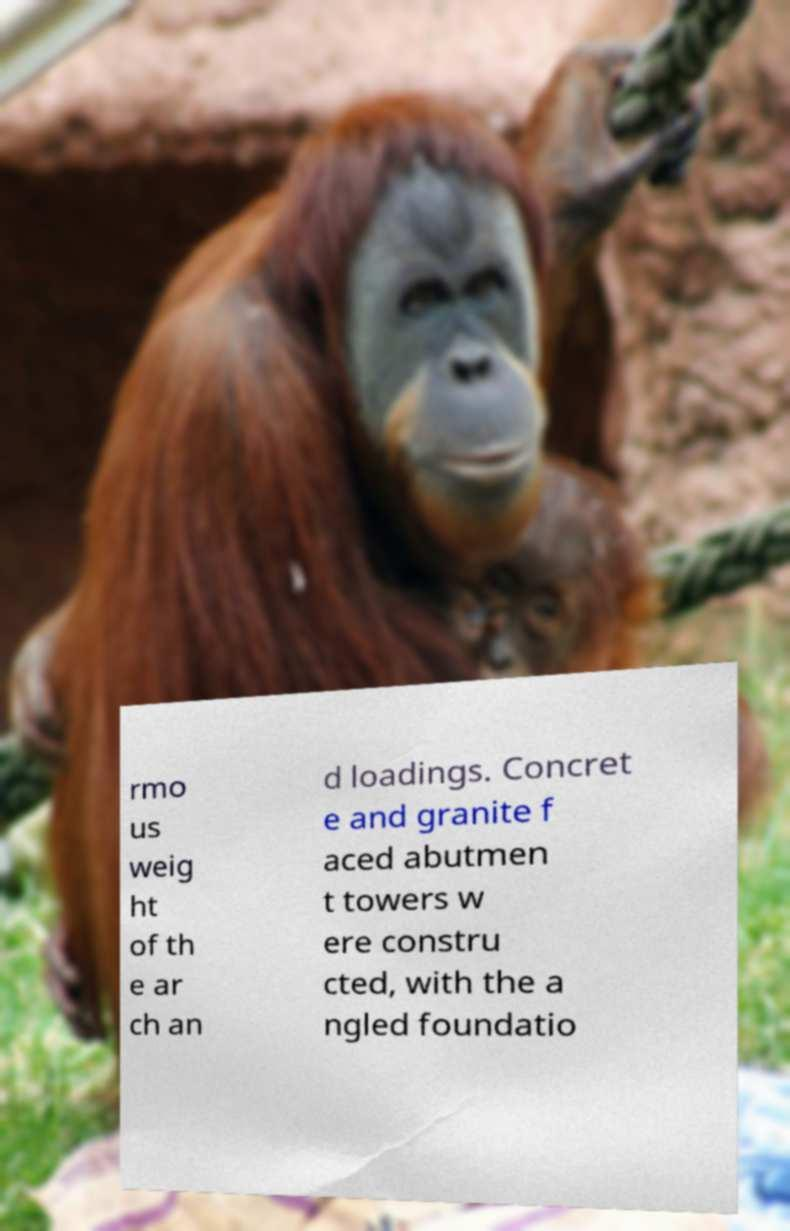Please read and relay the text visible in this image. What does it say? rmo us weig ht of th e ar ch an d loadings. Concret e and granite f aced abutmen t towers w ere constru cted, with the a ngled foundatio 